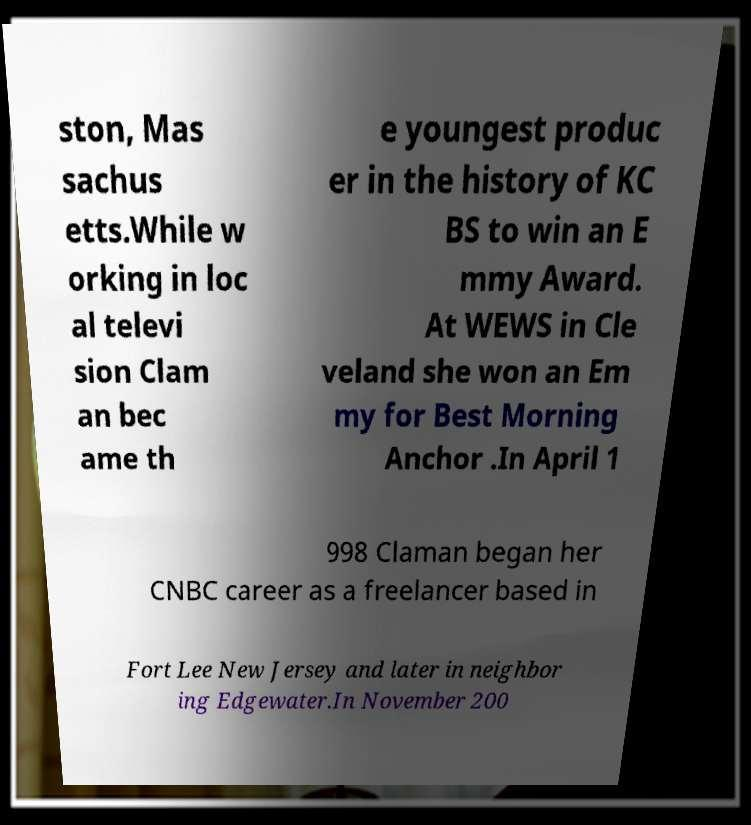Please identify and transcribe the text found in this image. ston, Mas sachus etts.While w orking in loc al televi sion Clam an bec ame th e youngest produc er in the history of KC BS to win an E mmy Award. At WEWS in Cle veland she won an Em my for Best Morning Anchor .In April 1 998 Claman began her CNBC career as a freelancer based in Fort Lee New Jersey and later in neighbor ing Edgewater.In November 200 